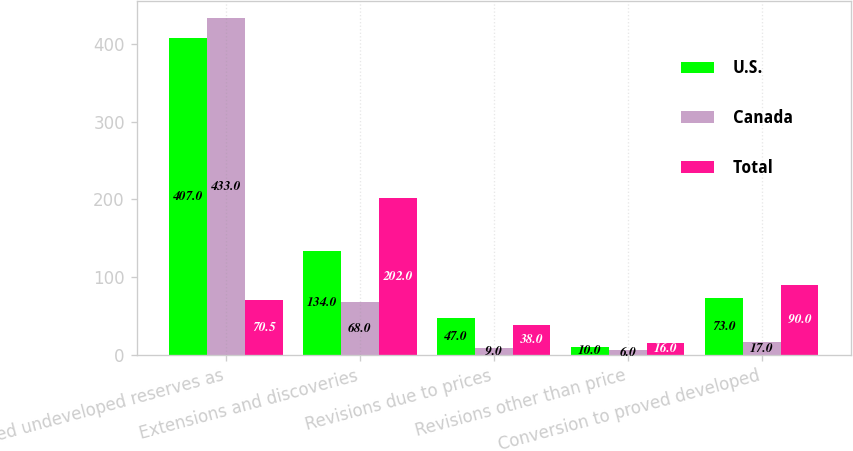<chart> <loc_0><loc_0><loc_500><loc_500><stacked_bar_chart><ecel><fcel>Proved undeveloped reserves as<fcel>Extensions and discoveries<fcel>Revisions due to prices<fcel>Revisions other than price<fcel>Conversion to proved developed<nl><fcel>U.S.<fcel>407<fcel>134<fcel>47<fcel>10<fcel>73<nl><fcel>Canada<fcel>433<fcel>68<fcel>9<fcel>6<fcel>17<nl><fcel>Total<fcel>70.5<fcel>202<fcel>38<fcel>16<fcel>90<nl></chart> 